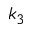<formula> <loc_0><loc_0><loc_500><loc_500>k _ { 3 }</formula> 